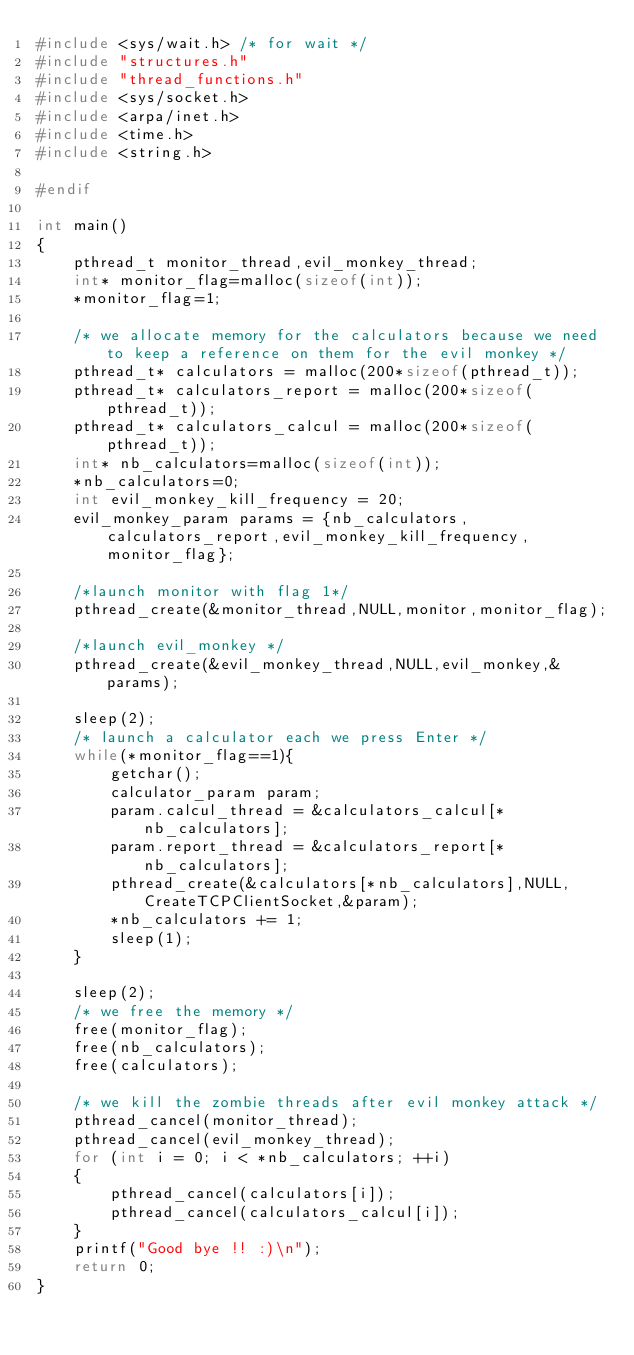Convert code to text. <code><loc_0><loc_0><loc_500><loc_500><_C_>#include <sys/wait.h> /* for wait */
#include "structures.h"
#include "thread_functions.h"
#include <sys/socket.h>
#include <arpa/inet.h> 
#include <time.h>
#include <string.h>

#endif

int main()
{
    pthread_t monitor_thread,evil_monkey_thread;
    int* monitor_flag=malloc(sizeof(int));
    *monitor_flag=1;

    /* we allocate memory for the calculators because we need to keep a reference on them for the evil monkey */
    pthread_t* calculators = malloc(200*sizeof(pthread_t));
    pthread_t* calculators_report = malloc(200*sizeof(pthread_t));
    pthread_t* calculators_calcul = malloc(200*sizeof(pthread_t));
    int* nb_calculators=malloc(sizeof(int));
    *nb_calculators=0;
    int evil_monkey_kill_frequency = 20;
    evil_monkey_param params = {nb_calculators,calculators_report,evil_monkey_kill_frequency,monitor_flag};

    /*launch monitor with flag 1*/
    pthread_create(&monitor_thread,NULL,monitor,monitor_flag);

    /*launch evil_monkey */
    pthread_create(&evil_monkey_thread,NULL,evil_monkey,&params);

    sleep(2);
    /* launch a calculator each we press Enter */
    while(*monitor_flag==1){
        getchar();
        calculator_param param; 
        param.calcul_thread = &calculators_calcul[*nb_calculators];
        param.report_thread = &calculators_report[*nb_calculators];
        pthread_create(&calculators[*nb_calculators],NULL,CreateTCPClientSocket,&param);
        *nb_calculators += 1;
        sleep(1);
    }

    sleep(2);
    /* we free the memory */
    free(monitor_flag);
    free(nb_calculators);
    free(calculators);

    /* we kill the zombie threads after evil monkey attack */
    pthread_cancel(monitor_thread);
    pthread_cancel(evil_monkey_thread);
    for (int i = 0; i < *nb_calculators; ++i)
    {
        pthread_cancel(calculators[i]);
        pthread_cancel(calculators_calcul[i]);
    }
    printf("Good bye !! :)\n");
    return 0;
}


</code> 